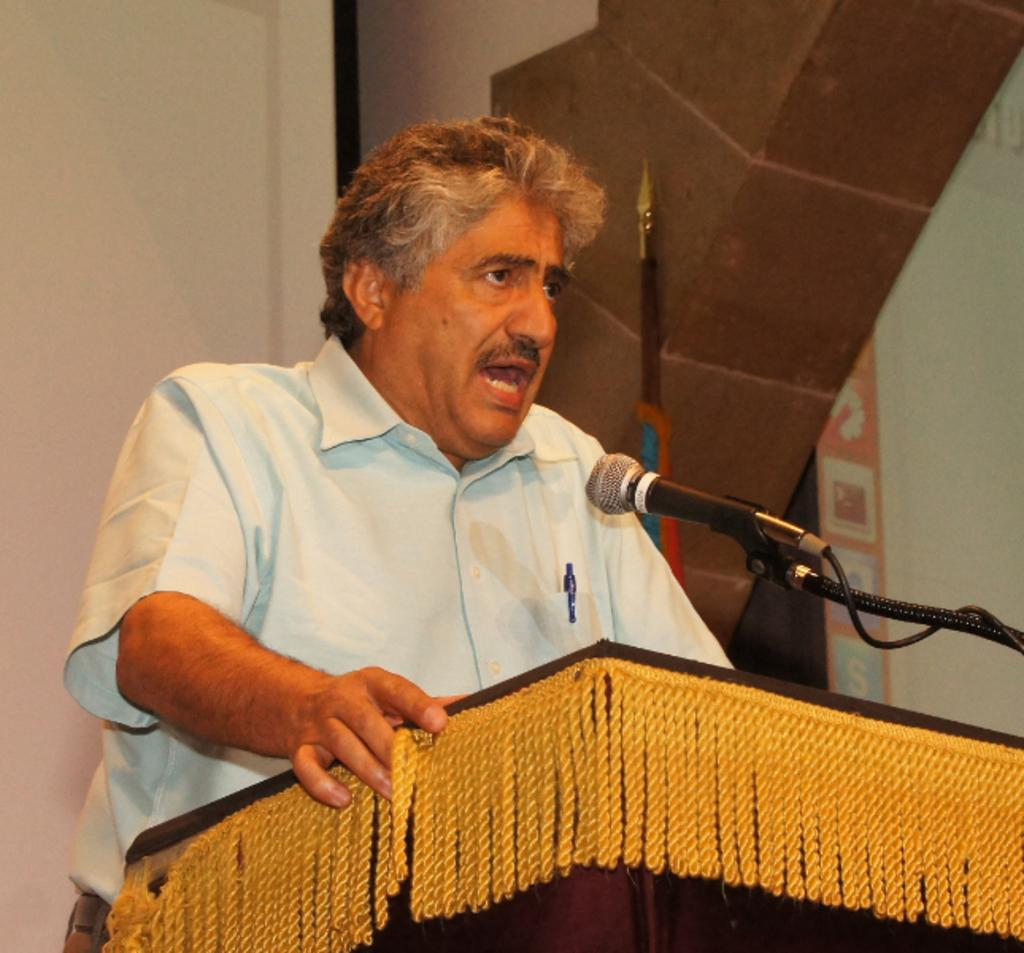What is the man in the image doing? The man is standing at the podium in the image. What is attached to the podium? A microphone is fixed to the podium. What can be seen in the background of the image? There are walls visible in the background of the image. What type of steam is coming out of the top of the man's head in the image? There is no steam coming out of the top of the man's head in the image. 